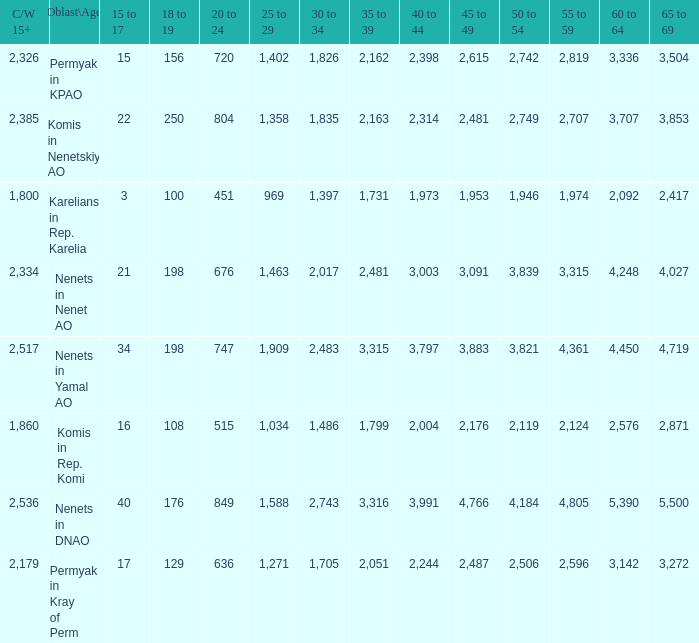What is the mean 55 to 59 when the C/W 15+ is greater than 2,385, and the 30 to 34 is 2,483, and the 35 to 39 is greater than 3,315? None. 